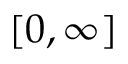Convert formula to latex. <formula><loc_0><loc_0><loc_500><loc_500>[ 0 , \infty ]</formula> 